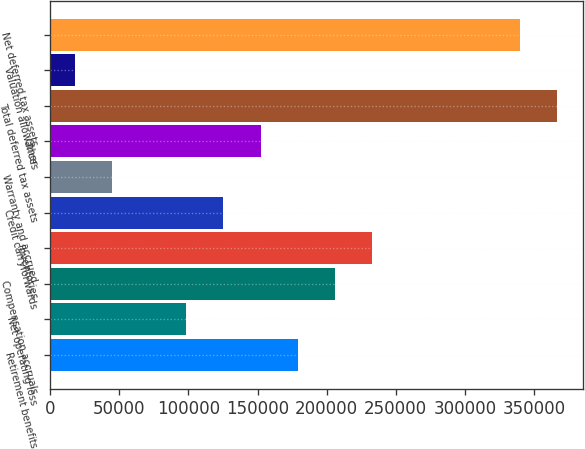Convert chart. <chart><loc_0><loc_0><loc_500><loc_500><bar_chart><fcel>Retirement benefits<fcel>Net operating loss<fcel>Compensation accruals<fcel>Inventories<fcel>Credit carryforwards<fcel>Warranty and accrued<fcel>Other<fcel>Total deferred tax assets<fcel>Valuation allowances<fcel>Net deferred tax assets<nl><fcel>179023<fcel>98498.9<fcel>205864<fcel>232705<fcel>125340<fcel>44816.3<fcel>152182<fcel>366912<fcel>17975<fcel>340071<nl></chart> 